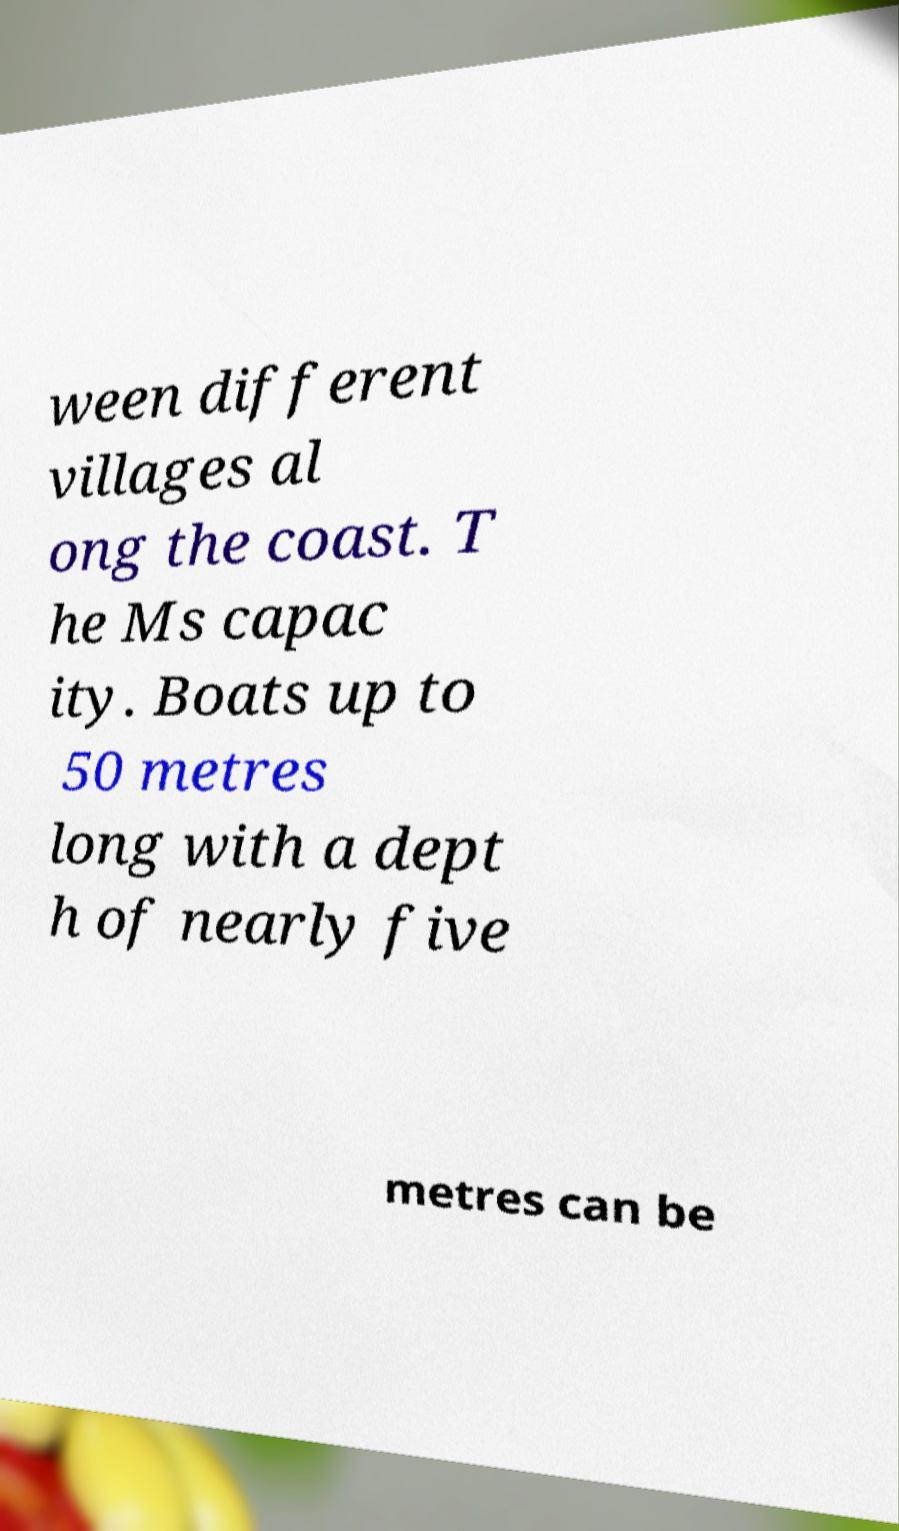What messages or text are displayed in this image? I need them in a readable, typed format. ween different villages al ong the coast. T he Ms capac ity. Boats up to 50 metres long with a dept h of nearly five metres can be 